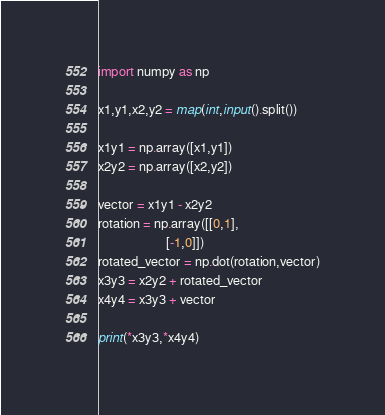<code> <loc_0><loc_0><loc_500><loc_500><_Python_>import numpy as np

x1,y1,x2,y2 = map(int,input().split())

x1y1 = np.array([x1,y1])
x2y2 = np.array([x2,y2])

vector = x1y1 - x2y2
rotation = np.array([[0,1],
                     [-1,0]])
rotated_vector = np.dot(rotation,vector)
x3y3 = x2y2 + rotated_vector
x4y4 = x3y3 + vector

print(*x3y3,*x4y4)</code> 